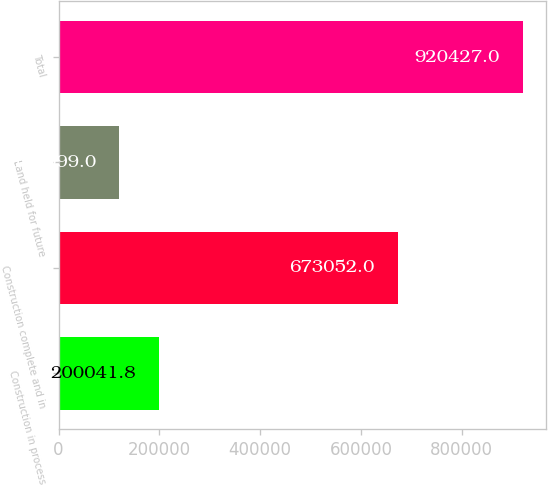<chart> <loc_0><loc_0><loc_500><loc_500><bar_chart><fcel>Construction in process<fcel>Construction complete and in<fcel>Land held for future<fcel>Total<nl><fcel>200042<fcel>673052<fcel>119999<fcel>920427<nl></chart> 